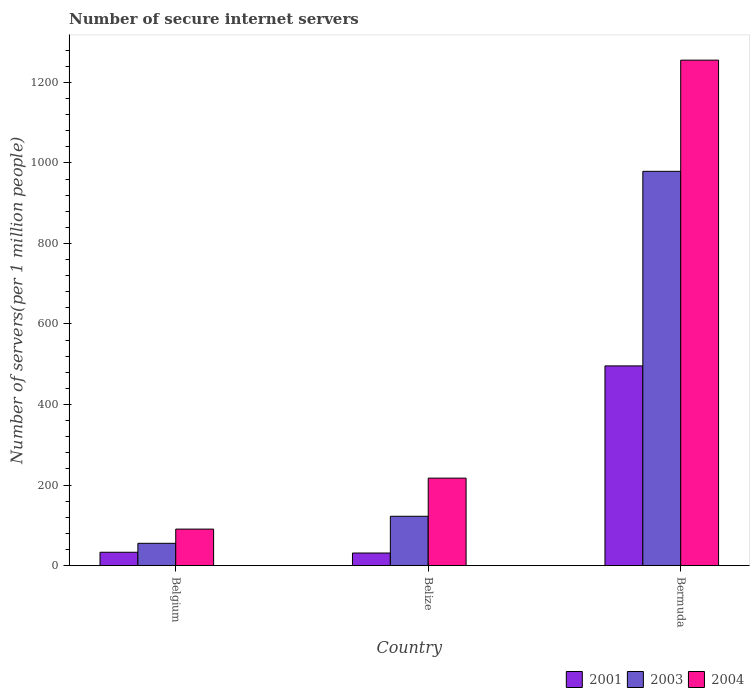Are the number of bars per tick equal to the number of legend labels?
Your answer should be very brief. Yes. Are the number of bars on each tick of the X-axis equal?
Your answer should be very brief. Yes. What is the label of the 1st group of bars from the left?
Keep it short and to the point. Belgium. What is the number of secure internet servers in 2001 in Belize?
Provide a succinct answer. 31.37. Across all countries, what is the maximum number of secure internet servers in 2001?
Make the answer very short. 495.97. Across all countries, what is the minimum number of secure internet servers in 2001?
Offer a very short reply. 31.37. In which country was the number of secure internet servers in 2004 maximum?
Keep it short and to the point. Bermuda. What is the total number of secure internet servers in 2004 in the graph?
Your response must be concise. 1563.2. What is the difference between the number of secure internet servers in 2003 in Belgium and that in Bermuda?
Provide a succinct answer. -923.56. What is the difference between the number of secure internet servers in 2004 in Belize and the number of secure internet servers in 2003 in Belgium?
Your answer should be very brief. 161.81. What is the average number of secure internet servers in 2004 per country?
Your answer should be very brief. 521.07. What is the difference between the number of secure internet servers of/in 2003 and number of secure internet servers of/in 2001 in Belize?
Your answer should be compact. 91.24. What is the ratio of the number of secure internet servers in 2003 in Belgium to that in Bermuda?
Provide a succinct answer. 0.06. Is the number of secure internet servers in 2003 in Belgium less than that in Bermuda?
Provide a succinct answer. Yes. What is the difference between the highest and the second highest number of secure internet servers in 2001?
Keep it short and to the point. 1.87. What is the difference between the highest and the lowest number of secure internet servers in 2001?
Your response must be concise. 464.59. Is the sum of the number of secure internet servers in 2003 in Belize and Bermuda greater than the maximum number of secure internet servers in 2004 across all countries?
Your answer should be very brief. No. What does the 1st bar from the right in Belgium represents?
Provide a succinct answer. 2004. Are all the bars in the graph horizontal?
Offer a terse response. No. How many countries are there in the graph?
Your response must be concise. 3. Are the values on the major ticks of Y-axis written in scientific E-notation?
Offer a very short reply. No. Does the graph contain any zero values?
Give a very brief answer. No. Does the graph contain grids?
Your answer should be compact. No. Where does the legend appear in the graph?
Keep it short and to the point. Bottom right. How many legend labels are there?
Provide a succinct answer. 3. How are the legend labels stacked?
Give a very brief answer. Horizontal. What is the title of the graph?
Provide a succinct answer. Number of secure internet servers. What is the label or title of the X-axis?
Give a very brief answer. Country. What is the label or title of the Y-axis?
Your response must be concise. Number of servers(per 1 million people). What is the Number of servers(per 1 million people) of 2001 in Belgium?
Offer a terse response. 33.25. What is the Number of servers(per 1 million people) in 2003 in Belgium?
Offer a very short reply. 55.51. What is the Number of servers(per 1 million people) of 2004 in Belgium?
Give a very brief answer. 90.78. What is the Number of servers(per 1 million people) in 2001 in Belize?
Ensure brevity in your answer.  31.37. What is the Number of servers(per 1 million people) in 2003 in Belize?
Give a very brief answer. 122.62. What is the Number of servers(per 1 million people) in 2004 in Belize?
Your response must be concise. 217.32. What is the Number of servers(per 1 million people) of 2001 in Bermuda?
Offer a very short reply. 495.97. What is the Number of servers(per 1 million people) in 2003 in Bermuda?
Offer a terse response. 979.08. What is the Number of servers(per 1 million people) in 2004 in Bermuda?
Ensure brevity in your answer.  1255.1. Across all countries, what is the maximum Number of servers(per 1 million people) in 2001?
Provide a succinct answer. 495.97. Across all countries, what is the maximum Number of servers(per 1 million people) of 2003?
Keep it short and to the point. 979.08. Across all countries, what is the maximum Number of servers(per 1 million people) of 2004?
Make the answer very short. 1255.1. Across all countries, what is the minimum Number of servers(per 1 million people) of 2001?
Offer a terse response. 31.37. Across all countries, what is the minimum Number of servers(per 1 million people) in 2003?
Keep it short and to the point. 55.51. Across all countries, what is the minimum Number of servers(per 1 million people) of 2004?
Provide a short and direct response. 90.78. What is the total Number of servers(per 1 million people) of 2001 in the graph?
Provide a short and direct response. 560.59. What is the total Number of servers(per 1 million people) in 2003 in the graph?
Make the answer very short. 1157.2. What is the total Number of servers(per 1 million people) in 2004 in the graph?
Your answer should be very brief. 1563.2. What is the difference between the Number of servers(per 1 million people) of 2001 in Belgium and that in Belize?
Your answer should be compact. 1.87. What is the difference between the Number of servers(per 1 million people) of 2003 in Belgium and that in Belize?
Your answer should be very brief. -67.1. What is the difference between the Number of servers(per 1 million people) of 2004 in Belgium and that in Belize?
Your answer should be very brief. -126.55. What is the difference between the Number of servers(per 1 million people) in 2001 in Belgium and that in Bermuda?
Your response must be concise. -462.72. What is the difference between the Number of servers(per 1 million people) of 2003 in Belgium and that in Bermuda?
Make the answer very short. -923.56. What is the difference between the Number of servers(per 1 million people) in 2004 in Belgium and that in Bermuda?
Offer a terse response. -1164.32. What is the difference between the Number of servers(per 1 million people) in 2001 in Belize and that in Bermuda?
Offer a terse response. -464.59. What is the difference between the Number of servers(per 1 million people) of 2003 in Belize and that in Bermuda?
Your answer should be compact. -856.46. What is the difference between the Number of servers(per 1 million people) of 2004 in Belize and that in Bermuda?
Offer a very short reply. -1037.77. What is the difference between the Number of servers(per 1 million people) in 2001 in Belgium and the Number of servers(per 1 million people) in 2003 in Belize?
Keep it short and to the point. -89.37. What is the difference between the Number of servers(per 1 million people) of 2001 in Belgium and the Number of servers(per 1 million people) of 2004 in Belize?
Your response must be concise. -184.08. What is the difference between the Number of servers(per 1 million people) of 2003 in Belgium and the Number of servers(per 1 million people) of 2004 in Belize?
Give a very brief answer. -161.81. What is the difference between the Number of servers(per 1 million people) of 2001 in Belgium and the Number of servers(per 1 million people) of 2003 in Bermuda?
Provide a short and direct response. -945.83. What is the difference between the Number of servers(per 1 million people) of 2001 in Belgium and the Number of servers(per 1 million people) of 2004 in Bermuda?
Make the answer very short. -1221.85. What is the difference between the Number of servers(per 1 million people) in 2003 in Belgium and the Number of servers(per 1 million people) in 2004 in Bermuda?
Give a very brief answer. -1199.59. What is the difference between the Number of servers(per 1 million people) in 2001 in Belize and the Number of servers(per 1 million people) in 2003 in Bermuda?
Make the answer very short. -947.7. What is the difference between the Number of servers(per 1 million people) of 2001 in Belize and the Number of servers(per 1 million people) of 2004 in Bermuda?
Provide a succinct answer. -1223.72. What is the difference between the Number of servers(per 1 million people) of 2003 in Belize and the Number of servers(per 1 million people) of 2004 in Bermuda?
Offer a terse response. -1132.48. What is the average Number of servers(per 1 million people) in 2001 per country?
Make the answer very short. 186.86. What is the average Number of servers(per 1 million people) of 2003 per country?
Your answer should be compact. 385.73. What is the average Number of servers(per 1 million people) of 2004 per country?
Offer a terse response. 521.07. What is the difference between the Number of servers(per 1 million people) of 2001 and Number of servers(per 1 million people) of 2003 in Belgium?
Ensure brevity in your answer.  -22.26. What is the difference between the Number of servers(per 1 million people) of 2001 and Number of servers(per 1 million people) of 2004 in Belgium?
Give a very brief answer. -57.53. What is the difference between the Number of servers(per 1 million people) of 2003 and Number of servers(per 1 million people) of 2004 in Belgium?
Make the answer very short. -35.27. What is the difference between the Number of servers(per 1 million people) in 2001 and Number of servers(per 1 million people) in 2003 in Belize?
Provide a short and direct response. -91.24. What is the difference between the Number of servers(per 1 million people) in 2001 and Number of servers(per 1 million people) in 2004 in Belize?
Your answer should be compact. -185.95. What is the difference between the Number of servers(per 1 million people) in 2003 and Number of servers(per 1 million people) in 2004 in Belize?
Offer a very short reply. -94.71. What is the difference between the Number of servers(per 1 million people) of 2001 and Number of servers(per 1 million people) of 2003 in Bermuda?
Make the answer very short. -483.11. What is the difference between the Number of servers(per 1 million people) in 2001 and Number of servers(per 1 million people) in 2004 in Bermuda?
Make the answer very short. -759.13. What is the difference between the Number of servers(per 1 million people) in 2003 and Number of servers(per 1 million people) in 2004 in Bermuda?
Make the answer very short. -276.02. What is the ratio of the Number of servers(per 1 million people) in 2001 in Belgium to that in Belize?
Provide a short and direct response. 1.06. What is the ratio of the Number of servers(per 1 million people) in 2003 in Belgium to that in Belize?
Provide a succinct answer. 0.45. What is the ratio of the Number of servers(per 1 million people) of 2004 in Belgium to that in Belize?
Ensure brevity in your answer.  0.42. What is the ratio of the Number of servers(per 1 million people) in 2001 in Belgium to that in Bermuda?
Your answer should be very brief. 0.07. What is the ratio of the Number of servers(per 1 million people) of 2003 in Belgium to that in Bermuda?
Make the answer very short. 0.06. What is the ratio of the Number of servers(per 1 million people) in 2004 in Belgium to that in Bermuda?
Offer a terse response. 0.07. What is the ratio of the Number of servers(per 1 million people) in 2001 in Belize to that in Bermuda?
Give a very brief answer. 0.06. What is the ratio of the Number of servers(per 1 million people) of 2003 in Belize to that in Bermuda?
Make the answer very short. 0.13. What is the ratio of the Number of servers(per 1 million people) in 2004 in Belize to that in Bermuda?
Offer a very short reply. 0.17. What is the difference between the highest and the second highest Number of servers(per 1 million people) of 2001?
Make the answer very short. 462.72. What is the difference between the highest and the second highest Number of servers(per 1 million people) in 2003?
Your answer should be compact. 856.46. What is the difference between the highest and the second highest Number of servers(per 1 million people) of 2004?
Offer a terse response. 1037.77. What is the difference between the highest and the lowest Number of servers(per 1 million people) in 2001?
Offer a very short reply. 464.59. What is the difference between the highest and the lowest Number of servers(per 1 million people) of 2003?
Ensure brevity in your answer.  923.56. What is the difference between the highest and the lowest Number of servers(per 1 million people) in 2004?
Your response must be concise. 1164.32. 